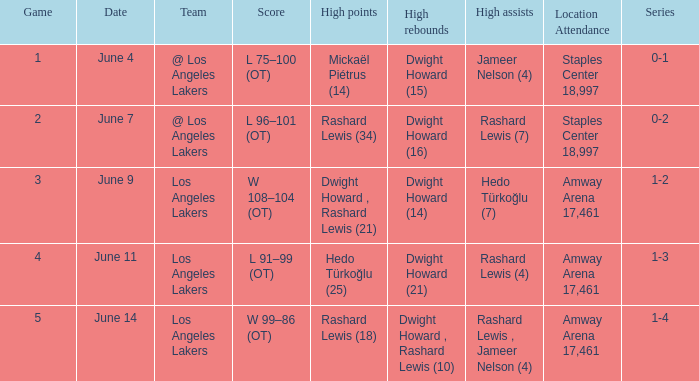Could you parse the entire table as a dict? {'header': ['Game', 'Date', 'Team', 'Score', 'High points', 'High rebounds', 'High assists', 'Location Attendance', 'Series'], 'rows': [['1', 'June 4', '@ Los Angeles Lakers', 'L 75–100 (OT)', 'Mickaël Piétrus (14)', 'Dwight Howard (15)', 'Jameer Nelson (4)', 'Staples Center 18,997', '0-1'], ['2', 'June 7', '@ Los Angeles Lakers', 'L 96–101 (OT)', 'Rashard Lewis (34)', 'Dwight Howard (16)', 'Rashard Lewis (7)', 'Staples Center 18,997', '0-2'], ['3', 'June 9', 'Los Angeles Lakers', 'W 108–104 (OT)', 'Dwight Howard , Rashard Lewis (21)', 'Dwight Howard (14)', 'Hedo Türkoğlu (7)', 'Amway Arena 17,461', '1-2'], ['4', 'June 11', 'Los Angeles Lakers', 'L 91–99 (OT)', 'Hedo Türkoğlu (25)', 'Dwight Howard (21)', 'Rashard Lewis (4)', 'Amway Arena 17,461', '1-3'], ['5', 'June 14', 'Los Angeles Lakers', 'W 99–86 (OT)', 'Rashard Lewis (18)', 'Dwight Howard , Rashard Lewis (10)', 'Rashard Lewis , Jameer Nelson (4)', 'Amway Arena 17,461', '1-4']]} Which series corresponds to the date "june 7"? 0-2. 